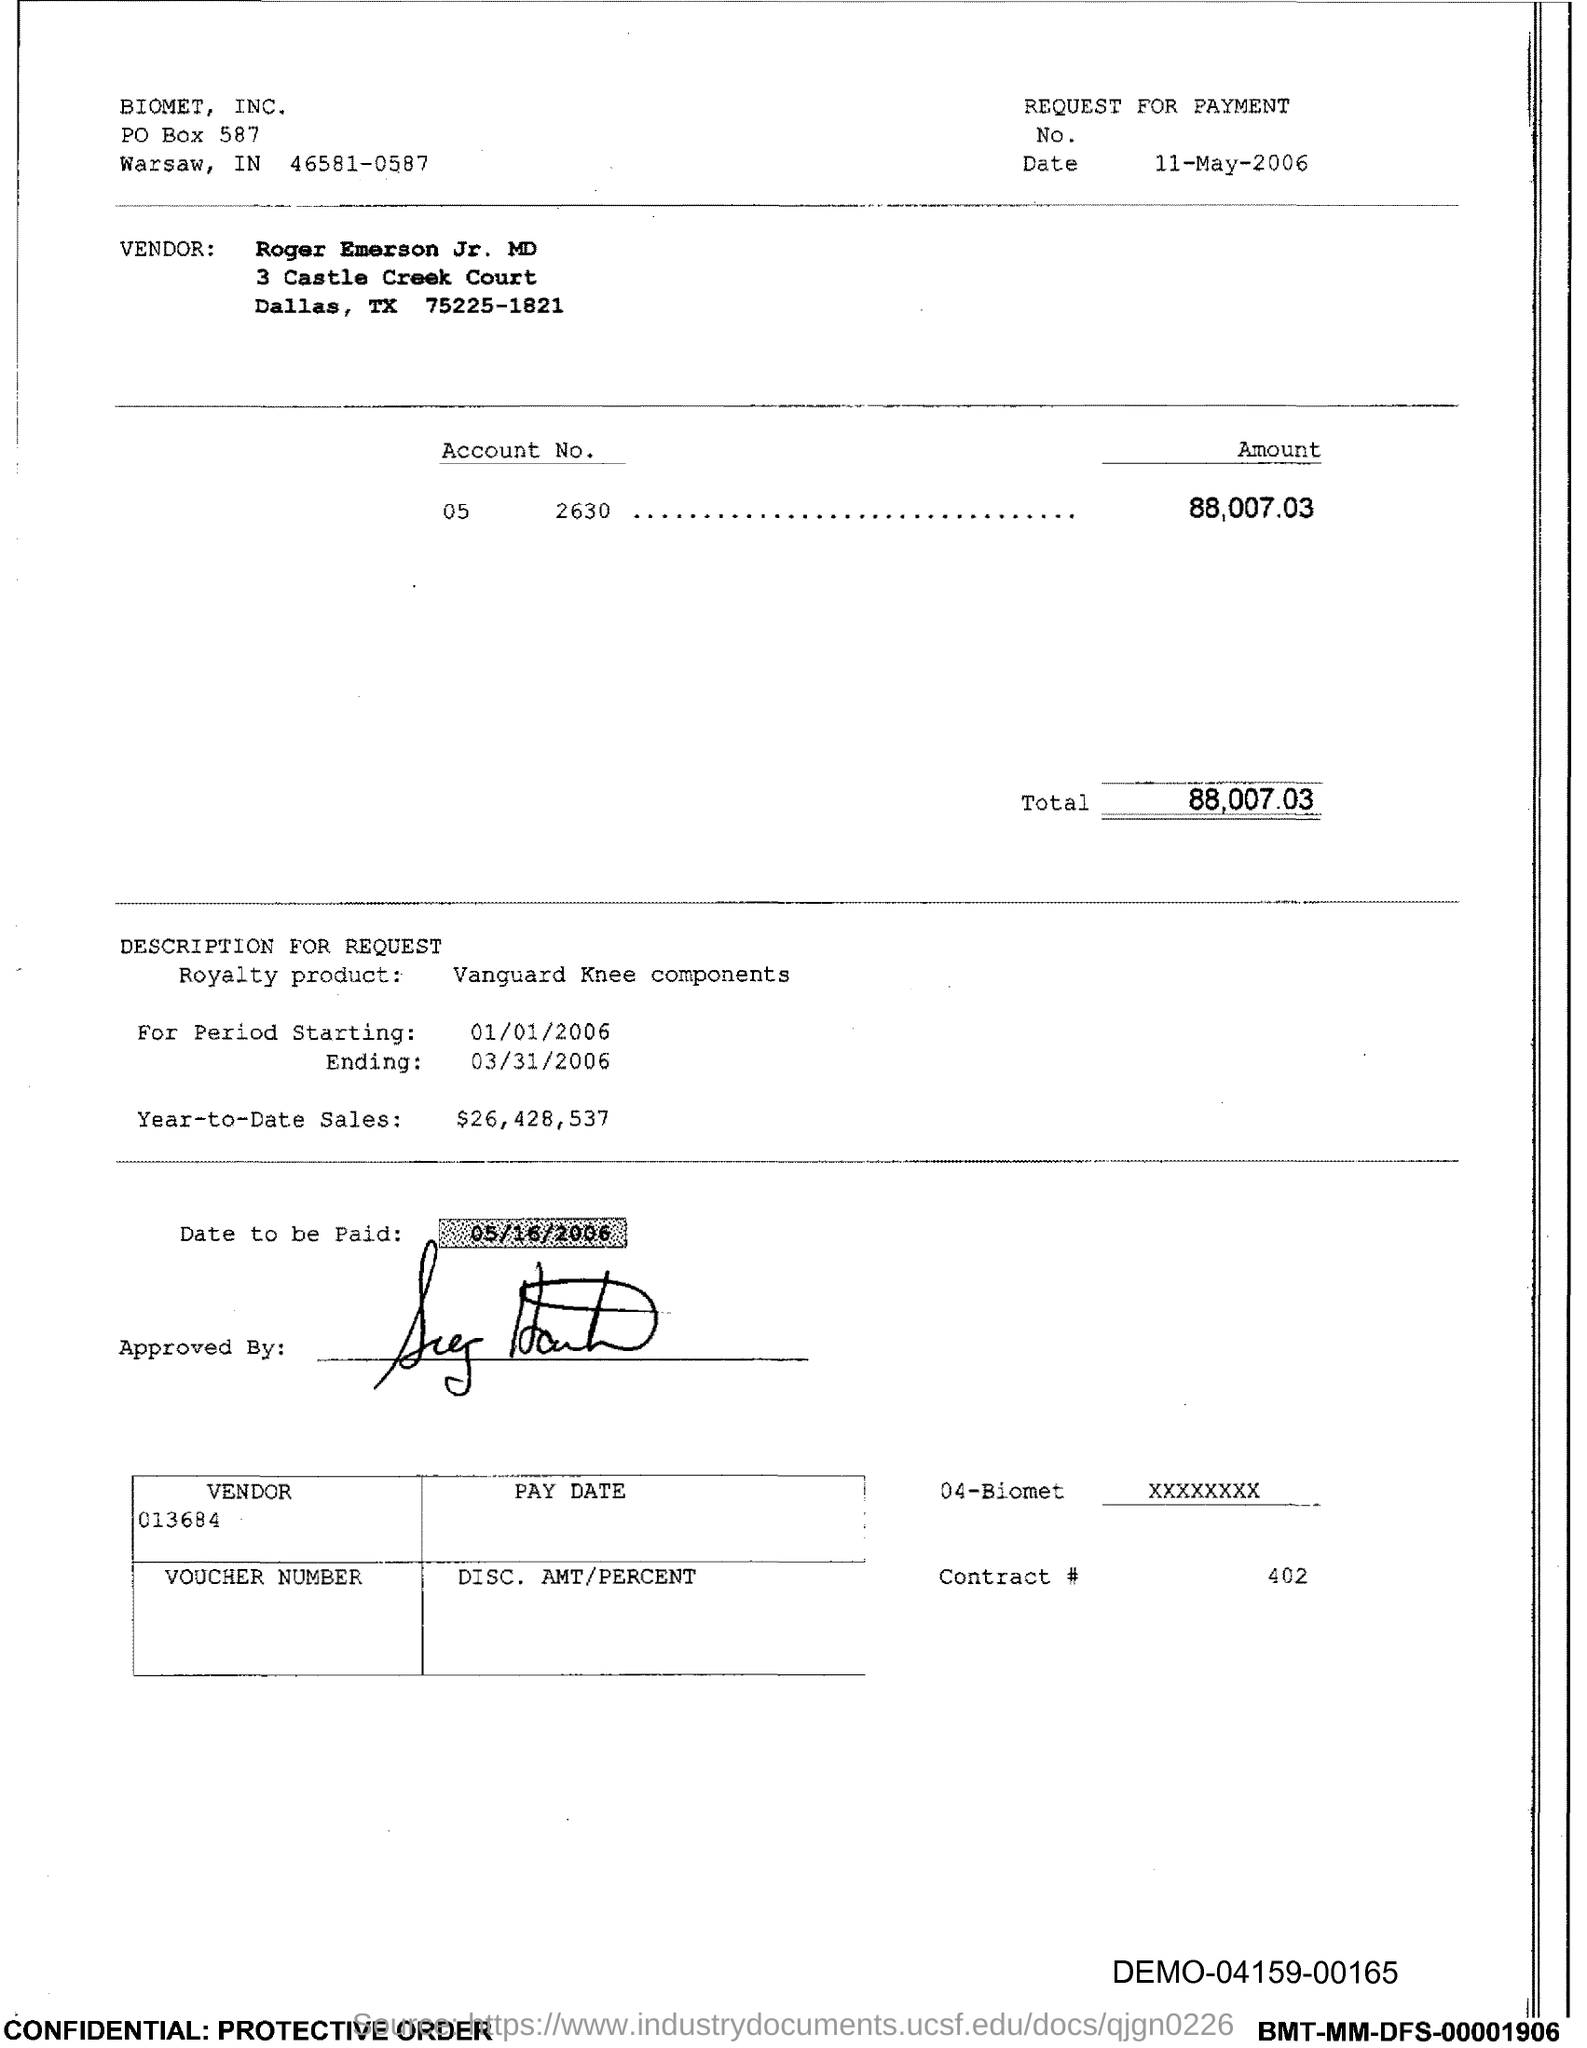What is the Date?
Make the answer very short. 11-May-2006. Who is the Vendor?
Make the answer very short. Roger Emerson Jr. MD. What is the Amount?
Provide a short and direct response. 88,007.03. What is the Total?
Your response must be concise. 88,007.03. What is the Starting period?
Provide a succinct answer. 01/01/2006. What is the Year-to-Date Sales?
Your answer should be compact. $26,428,537. When is the Date to be paid?
Offer a terse response. 05/16/2006. 